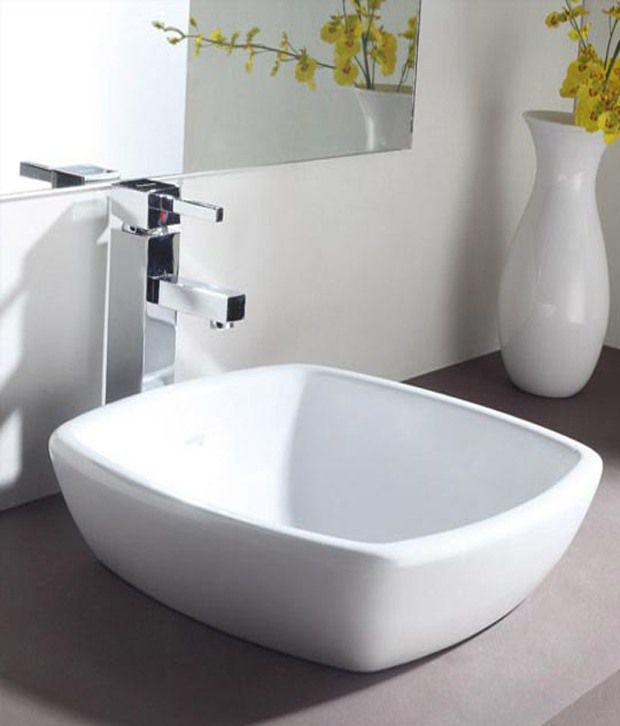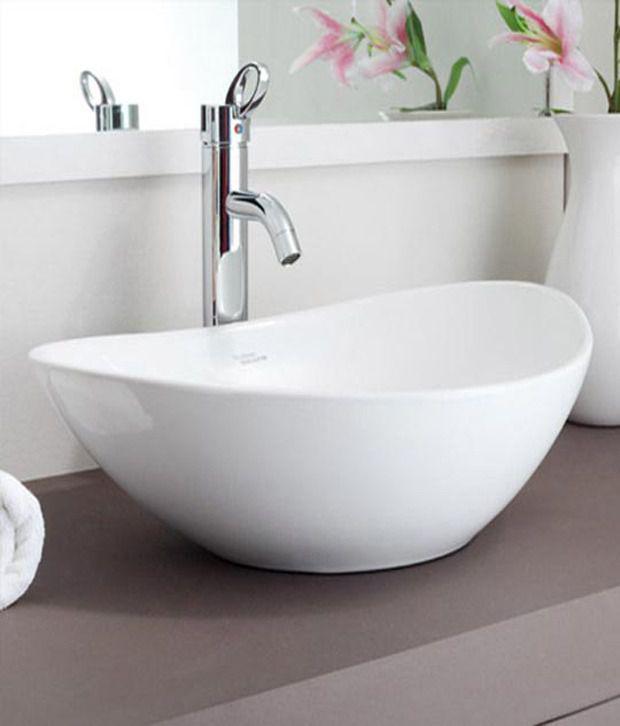The first image is the image on the left, the second image is the image on the right. For the images displayed, is the sentence "In one of the images there is a vase with yellow flowers placed on a counter next to a sink." factually correct? Answer yes or no. Yes. 